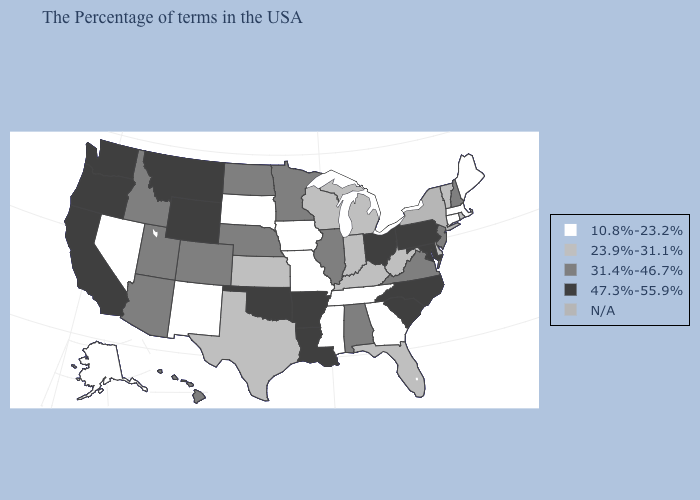What is the value of New York?
Write a very short answer. N/A. What is the value of Iowa?
Short answer required. 10.8%-23.2%. Name the states that have a value in the range 47.3%-55.9%?
Quick response, please. Maryland, Pennsylvania, North Carolina, South Carolina, Ohio, Louisiana, Arkansas, Oklahoma, Wyoming, Montana, California, Washington, Oregon. What is the lowest value in the Northeast?
Be succinct. 10.8%-23.2%. What is the value of Oklahoma?
Concise answer only. 47.3%-55.9%. What is the value of New York?
Write a very short answer. N/A. What is the highest value in the MidWest ?
Give a very brief answer. 47.3%-55.9%. Name the states that have a value in the range 47.3%-55.9%?
Write a very short answer. Maryland, Pennsylvania, North Carolina, South Carolina, Ohio, Louisiana, Arkansas, Oklahoma, Wyoming, Montana, California, Washington, Oregon. What is the value of Rhode Island?
Be succinct. 23.9%-31.1%. Which states have the lowest value in the USA?
Short answer required. Maine, Massachusetts, Connecticut, Georgia, Tennessee, Mississippi, Missouri, Iowa, South Dakota, New Mexico, Nevada, Alaska. How many symbols are there in the legend?
Answer briefly. 5. Among the states that border Michigan , does Ohio have the highest value?
Give a very brief answer. Yes. Name the states that have a value in the range 23.9%-31.1%?
Keep it brief. Rhode Island, Vermont, Delaware, West Virginia, Florida, Michigan, Kentucky, Indiana, Wisconsin, Kansas, Texas. What is the value of Louisiana?
Concise answer only. 47.3%-55.9%. Among the states that border Alabama , does Florida have the lowest value?
Concise answer only. No. 